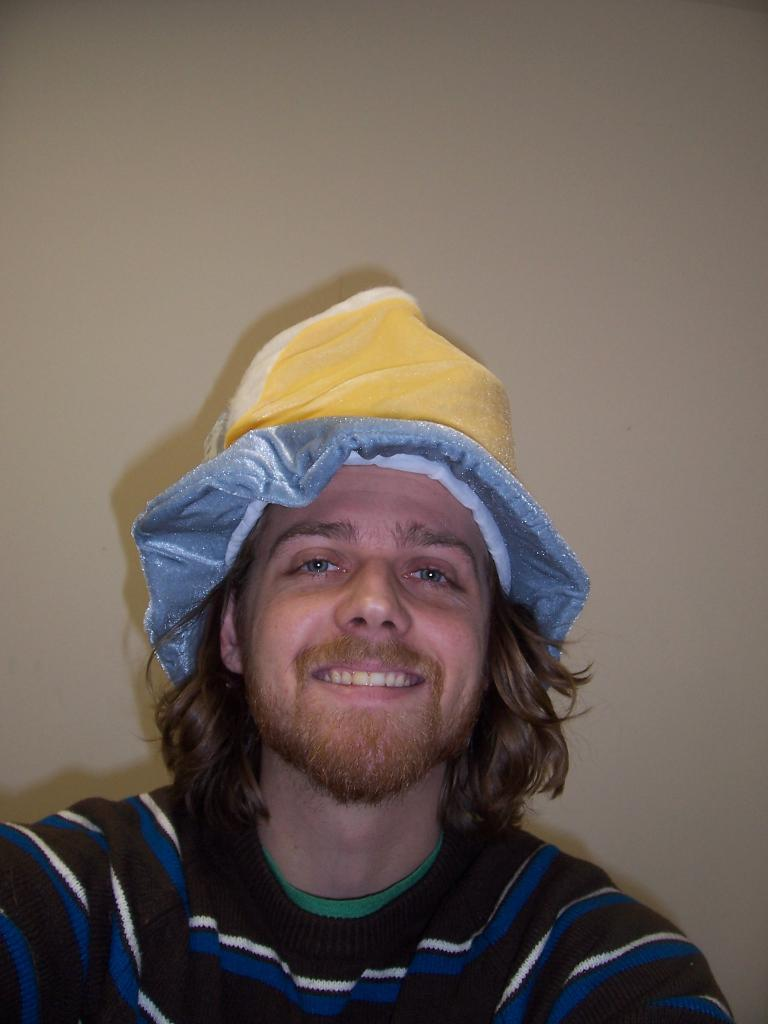What is the main subject of the image? The main subject of the image is a man. What is the man wearing on his head? The man is wearing a cap. What is the man's facial expression in the image? The man is smiling. What can be seen in the background of the image? There is a wall in the background of the image. What type of lettuce is the man holding in the image? There is no lettuce present in the image; the man is not holding any lettuce. 